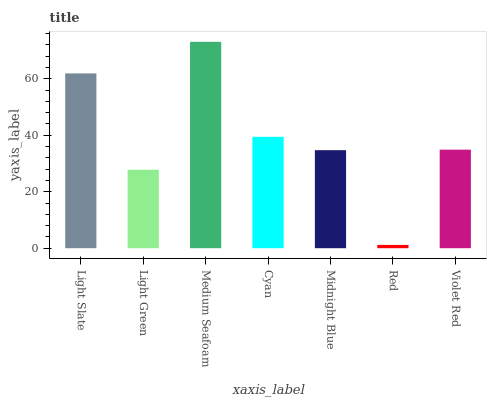Is Light Green the minimum?
Answer yes or no. No. Is Light Green the maximum?
Answer yes or no. No. Is Light Slate greater than Light Green?
Answer yes or no. Yes. Is Light Green less than Light Slate?
Answer yes or no. Yes. Is Light Green greater than Light Slate?
Answer yes or no. No. Is Light Slate less than Light Green?
Answer yes or no. No. Is Violet Red the high median?
Answer yes or no. Yes. Is Violet Red the low median?
Answer yes or no. Yes. Is Cyan the high median?
Answer yes or no. No. Is Light Slate the low median?
Answer yes or no. No. 